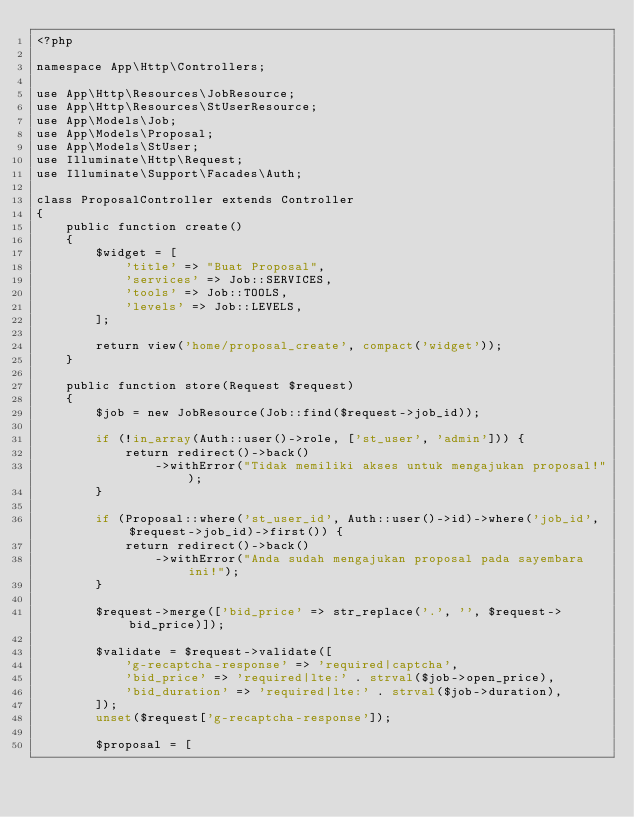<code> <loc_0><loc_0><loc_500><loc_500><_PHP_><?php

namespace App\Http\Controllers;

use App\Http\Resources\JobResource;
use App\Http\Resources\StUserResource;
use App\Models\Job;
use App\Models\Proposal;
use App\Models\StUser;
use Illuminate\Http\Request;
use Illuminate\Support\Facades\Auth;

class ProposalController extends Controller
{
    public function create()
    {
        $widget = [
            'title' => "Buat Proposal",
            'services' => Job::SERVICES,
            'tools' => Job::TOOLS,
            'levels' => Job::LEVELS,
        ];

        return view('home/proposal_create', compact('widget'));
    }

    public function store(Request $request)
    {
        $job = new JobResource(Job::find($request->job_id));

        if (!in_array(Auth::user()->role, ['st_user', 'admin'])) {
            return redirect()->back()
                ->withError("Tidak memiliki akses untuk mengajukan proposal!");
        }

        if (Proposal::where('st_user_id', Auth::user()->id)->where('job_id', $request->job_id)->first()) {
            return redirect()->back()
                ->withError("Anda sudah mengajukan proposal pada sayembara ini!");
        }

        $request->merge(['bid_price' => str_replace('.', '', $request->bid_price)]);

        $validate = $request->validate([
            'g-recaptcha-response' => 'required|captcha',
            'bid_price' => 'required|lte:' . strval($job->open_price),
            'bid_duration' => 'required|lte:' . strval($job->duration),
        ]);
        unset($request['g-recaptcha-response']);

        $proposal = [</code> 